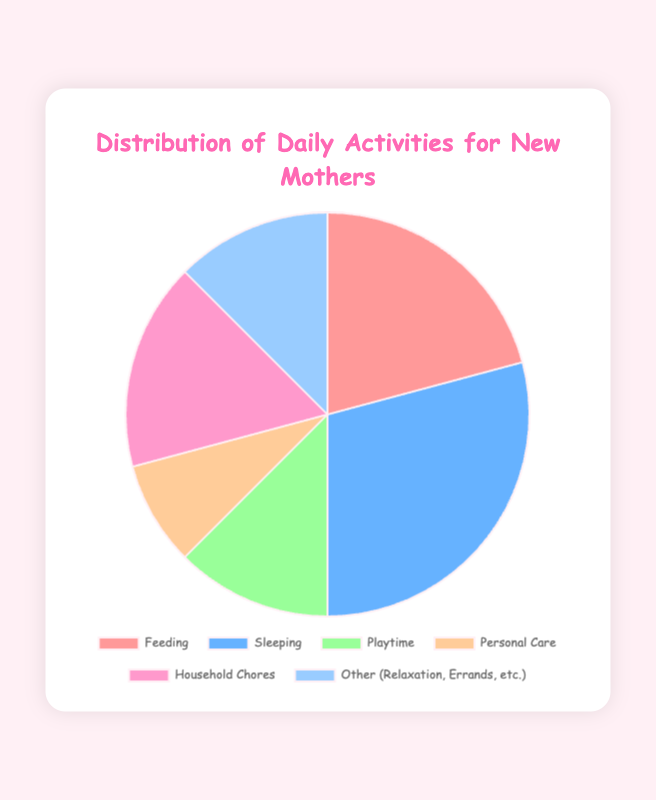What's the total time spent on Feeding and Personal Care each day? To find the total time spent on both activities, add the hours spent on Feeding (5 hours) and Personal Care (2 hours). The total is 5 + 2 = 7 hours.
Answer: 7 hours Which activity takes up the most time? The activity with the most time is the one with the largest slice in the pie chart. Feeding takes 5 hours, Sleeping takes 7 hours, Playtime takes 3 hours, Personal Care takes 2 hours, Household Chores takes 4 hours, and Other activities take 3 hours. Therefore, Sleeping takes the most time with 7 hours.
Answer: Sleeping How much more time is spent on Feeding than on Playtime? To find how much more time is spent on Feeding compared to Playtime, subtract the hours spent on Playtime (3 hours) from the hours spent on Feeding (5 hours). The difference is 5 - 3 = 2 hours.
Answer: 2 hours What is the average time spent on all activities per day? To find the average, add up all the hours and divide by the number of activities. The total hours are 5 (Feeding) + 7 (Sleeping) + 3 (Playtime) + 2 (Personal Care) + 4 (Household Chores) + 3 (Other activities) = 24 hours. There are 6 activities, so the average is 24 / 6 = 4 hours.
Answer: 4 hours Which activity consumes the least time? The activity with the smallest slice in the pie chart is the one that takes the least time. From the data, Personal Care takes 2 hours, which is the least.
Answer: Personal Care Is the time spent on Household Chores greater than that spent on Playtime? Compare the hours spent on Household Chores (4 hours) to the hours spent on Playtime (3 hours). Since 4 is greater than 3, the time spent on Household Chores is greater.
Answer: Yes What is the combined time for Playtime, Personal Care, and Other activities? Add the hours for Playtime (3 hours), Personal Care (2 hours), and Other activities (3 hours) to find the combined time. The total is 3 + 2 + 3 = 8 hours.
Answer: 8 hours If a mother wants to have equal time for each activity, how many hours should she ideally spend on each one? If the mother wants to spend equal time on each of the 6 activities, divide the total hours in a day (24 hours) by the number of activities. 24 / 6 = 4 hours per activity.
Answer: 4 hours 